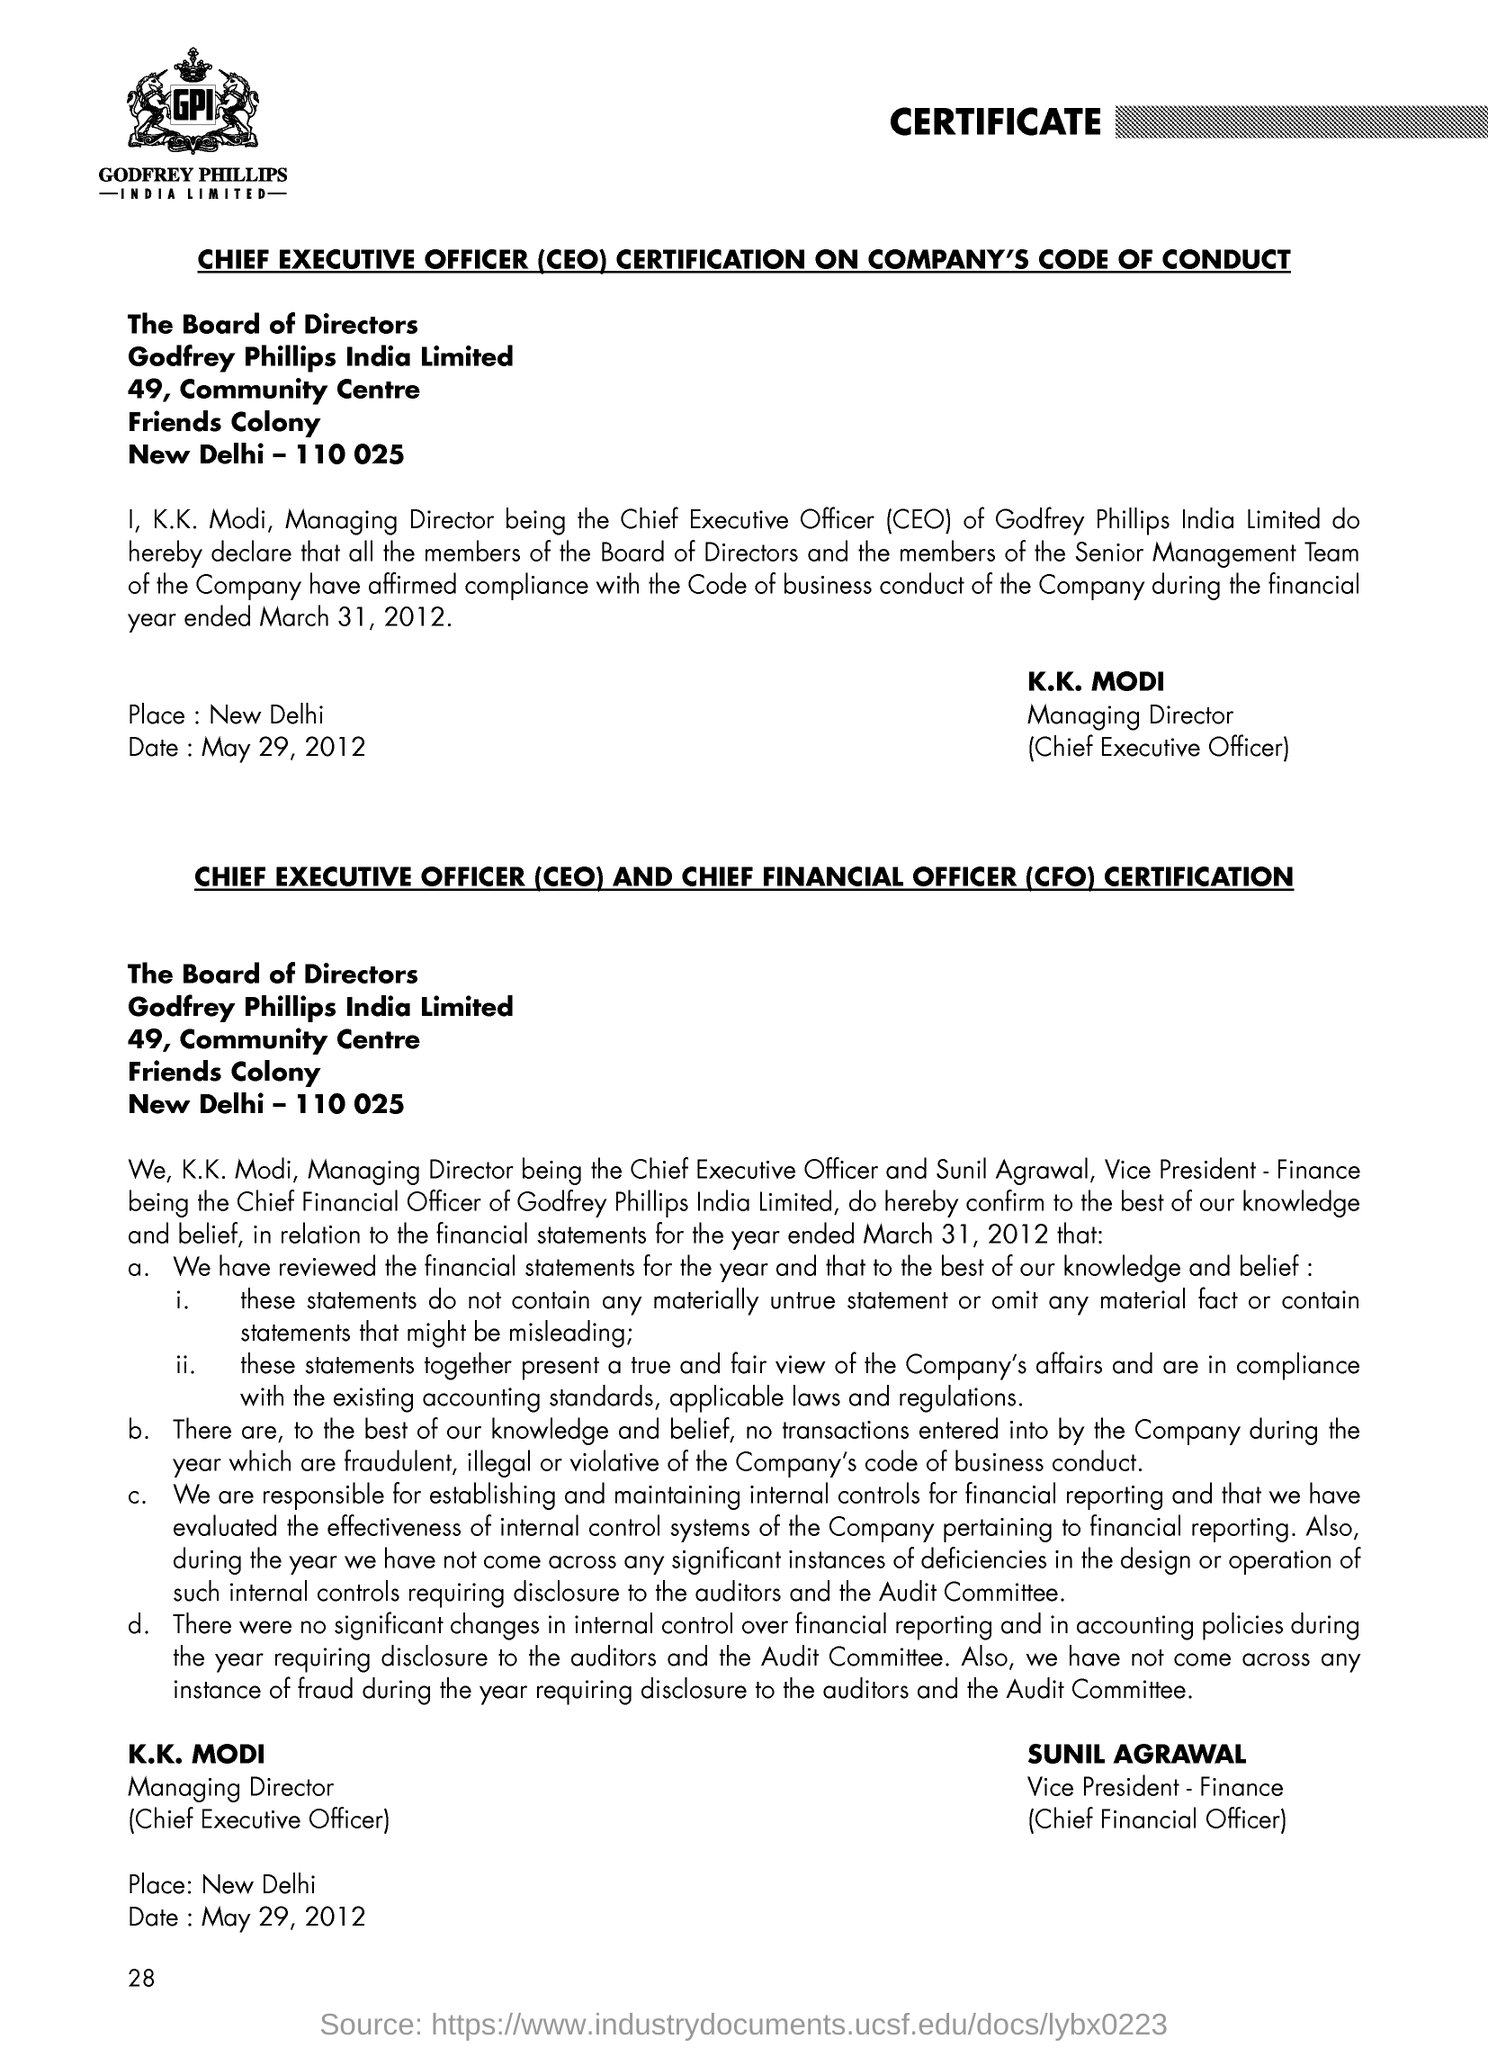Outline some significant characteristics in this image. The acronym "CEO" stands for "Chief Executive Officer. The full form of CFO is Chief Financial Officer. The date mentioned is May 29, 2012. 